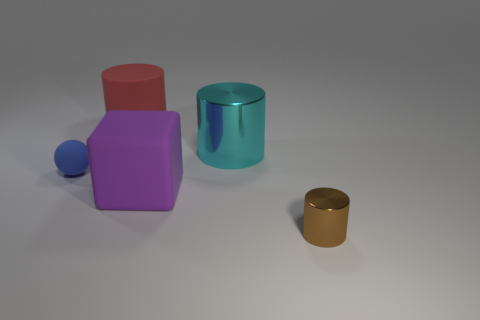What number of things are either cyan cylinders or spheres?
Provide a succinct answer. 2. What shape is the object that is right of the purple thing and left of the small brown shiny thing?
Your answer should be compact. Cylinder. Is the material of the thing that is in front of the purple rubber cube the same as the cyan cylinder?
Give a very brief answer. Yes. How many objects are either rubber things or metal cylinders behind the blue matte object?
Your answer should be very brief. 4. The cylinder that is the same material as the blue thing is what color?
Make the answer very short. Red. How many tiny blue spheres are made of the same material as the big cube?
Make the answer very short. 1. How many brown shiny cylinders are there?
Your response must be concise. 1. There is a metal thing behind the purple rubber object; is its color the same as the small thing on the left side of the big red thing?
Provide a short and direct response. No. How many big cyan shiny cylinders are in front of the block?
Provide a short and direct response. 0. Is there another large cyan metallic thing that has the same shape as the cyan metallic object?
Offer a very short reply. No. 